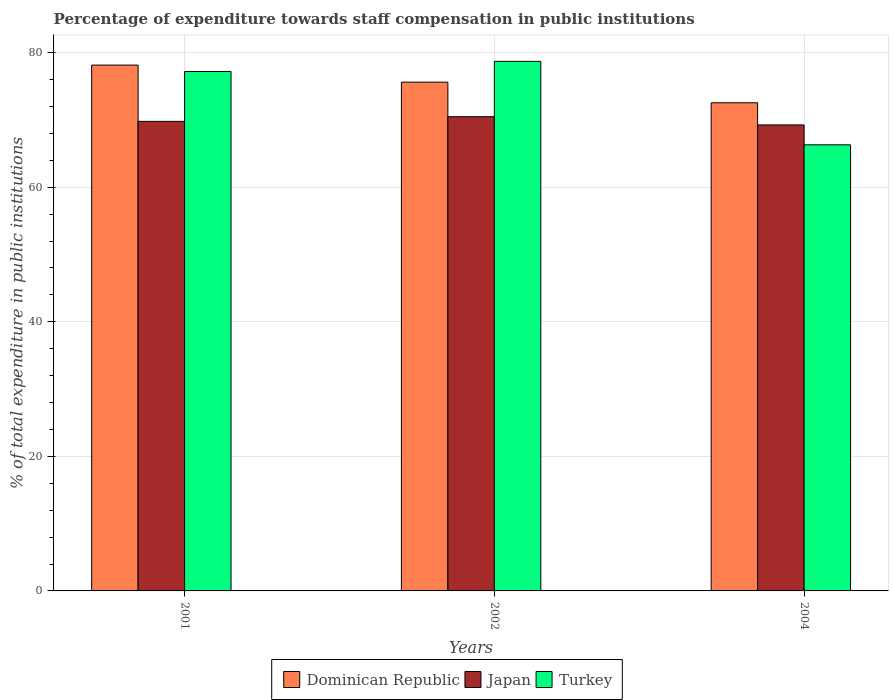How many different coloured bars are there?
Make the answer very short. 3. Are the number of bars per tick equal to the number of legend labels?
Provide a short and direct response. Yes. In how many cases, is the number of bars for a given year not equal to the number of legend labels?
Provide a succinct answer. 0. What is the percentage of expenditure towards staff compensation in Turkey in 2001?
Your answer should be very brief. 77.2. Across all years, what is the maximum percentage of expenditure towards staff compensation in Turkey?
Offer a very short reply. 78.71. Across all years, what is the minimum percentage of expenditure towards staff compensation in Dominican Republic?
Your answer should be very brief. 72.55. In which year was the percentage of expenditure towards staff compensation in Dominican Republic minimum?
Make the answer very short. 2004. What is the total percentage of expenditure towards staff compensation in Dominican Republic in the graph?
Your answer should be very brief. 226.33. What is the difference between the percentage of expenditure towards staff compensation in Japan in 2001 and that in 2002?
Provide a succinct answer. -0.69. What is the difference between the percentage of expenditure towards staff compensation in Japan in 2002 and the percentage of expenditure towards staff compensation in Turkey in 2004?
Give a very brief answer. 4.18. What is the average percentage of expenditure towards staff compensation in Japan per year?
Provide a short and direct response. 69.85. In the year 2002, what is the difference between the percentage of expenditure towards staff compensation in Turkey and percentage of expenditure towards staff compensation in Japan?
Ensure brevity in your answer.  8.23. In how many years, is the percentage of expenditure towards staff compensation in Japan greater than 32 %?
Your answer should be very brief. 3. What is the ratio of the percentage of expenditure towards staff compensation in Japan in 2001 to that in 2002?
Provide a succinct answer. 0.99. Is the percentage of expenditure towards staff compensation in Japan in 2001 less than that in 2004?
Your response must be concise. No. Is the difference between the percentage of expenditure towards staff compensation in Turkey in 2001 and 2002 greater than the difference between the percentage of expenditure towards staff compensation in Japan in 2001 and 2002?
Give a very brief answer. No. What is the difference between the highest and the second highest percentage of expenditure towards staff compensation in Turkey?
Ensure brevity in your answer.  1.51. What is the difference between the highest and the lowest percentage of expenditure towards staff compensation in Japan?
Provide a succinct answer. 1.22. Is the sum of the percentage of expenditure towards staff compensation in Turkey in 2002 and 2004 greater than the maximum percentage of expenditure towards staff compensation in Dominican Republic across all years?
Your answer should be very brief. Yes. What does the 3rd bar from the left in 2001 represents?
Your answer should be compact. Turkey. How many bars are there?
Provide a short and direct response. 9. What is the difference between two consecutive major ticks on the Y-axis?
Your answer should be compact. 20. Are the values on the major ticks of Y-axis written in scientific E-notation?
Make the answer very short. No. Does the graph contain any zero values?
Your answer should be compact. No. Does the graph contain grids?
Keep it short and to the point. Yes. How are the legend labels stacked?
Your answer should be compact. Horizontal. What is the title of the graph?
Ensure brevity in your answer.  Percentage of expenditure towards staff compensation in public institutions. What is the label or title of the X-axis?
Offer a terse response. Years. What is the label or title of the Y-axis?
Provide a short and direct response. % of total expenditure in public institutions. What is the % of total expenditure in public institutions in Dominican Republic in 2001?
Keep it short and to the point. 78.15. What is the % of total expenditure in public institutions in Japan in 2001?
Your response must be concise. 69.79. What is the % of total expenditure in public institutions of Turkey in 2001?
Your response must be concise. 77.2. What is the % of total expenditure in public institutions in Dominican Republic in 2002?
Ensure brevity in your answer.  75.62. What is the % of total expenditure in public institutions of Japan in 2002?
Provide a short and direct response. 70.48. What is the % of total expenditure in public institutions in Turkey in 2002?
Provide a succinct answer. 78.71. What is the % of total expenditure in public institutions of Dominican Republic in 2004?
Keep it short and to the point. 72.55. What is the % of total expenditure in public institutions of Japan in 2004?
Keep it short and to the point. 69.26. What is the % of total expenditure in public institutions in Turkey in 2004?
Offer a terse response. 66.3. Across all years, what is the maximum % of total expenditure in public institutions of Dominican Republic?
Provide a succinct answer. 78.15. Across all years, what is the maximum % of total expenditure in public institutions of Japan?
Keep it short and to the point. 70.48. Across all years, what is the maximum % of total expenditure in public institutions in Turkey?
Your answer should be compact. 78.71. Across all years, what is the minimum % of total expenditure in public institutions of Dominican Republic?
Provide a succinct answer. 72.55. Across all years, what is the minimum % of total expenditure in public institutions of Japan?
Offer a very short reply. 69.26. Across all years, what is the minimum % of total expenditure in public institutions in Turkey?
Offer a very short reply. 66.3. What is the total % of total expenditure in public institutions of Dominican Republic in the graph?
Your answer should be very brief. 226.33. What is the total % of total expenditure in public institutions of Japan in the graph?
Keep it short and to the point. 209.54. What is the total % of total expenditure in public institutions in Turkey in the graph?
Ensure brevity in your answer.  222.22. What is the difference between the % of total expenditure in public institutions of Dominican Republic in 2001 and that in 2002?
Offer a terse response. 2.53. What is the difference between the % of total expenditure in public institutions of Japan in 2001 and that in 2002?
Your answer should be compact. -0.69. What is the difference between the % of total expenditure in public institutions in Turkey in 2001 and that in 2002?
Provide a short and direct response. -1.51. What is the difference between the % of total expenditure in public institutions in Dominican Republic in 2001 and that in 2004?
Offer a terse response. 5.6. What is the difference between the % of total expenditure in public institutions in Japan in 2001 and that in 2004?
Provide a short and direct response. 0.53. What is the difference between the % of total expenditure in public institutions in Turkey in 2001 and that in 2004?
Offer a very short reply. 10.9. What is the difference between the % of total expenditure in public institutions in Dominican Republic in 2002 and that in 2004?
Your response must be concise. 3.06. What is the difference between the % of total expenditure in public institutions in Japan in 2002 and that in 2004?
Make the answer very short. 1.22. What is the difference between the % of total expenditure in public institutions of Turkey in 2002 and that in 2004?
Your answer should be very brief. 12.41. What is the difference between the % of total expenditure in public institutions in Dominican Republic in 2001 and the % of total expenditure in public institutions in Japan in 2002?
Offer a terse response. 7.67. What is the difference between the % of total expenditure in public institutions in Dominican Republic in 2001 and the % of total expenditure in public institutions in Turkey in 2002?
Provide a short and direct response. -0.56. What is the difference between the % of total expenditure in public institutions of Japan in 2001 and the % of total expenditure in public institutions of Turkey in 2002?
Offer a very short reply. -8.92. What is the difference between the % of total expenditure in public institutions of Dominican Republic in 2001 and the % of total expenditure in public institutions of Japan in 2004?
Your response must be concise. 8.89. What is the difference between the % of total expenditure in public institutions of Dominican Republic in 2001 and the % of total expenditure in public institutions of Turkey in 2004?
Provide a succinct answer. 11.85. What is the difference between the % of total expenditure in public institutions in Japan in 2001 and the % of total expenditure in public institutions in Turkey in 2004?
Keep it short and to the point. 3.49. What is the difference between the % of total expenditure in public institutions in Dominican Republic in 2002 and the % of total expenditure in public institutions in Japan in 2004?
Make the answer very short. 6.36. What is the difference between the % of total expenditure in public institutions of Dominican Republic in 2002 and the % of total expenditure in public institutions of Turkey in 2004?
Ensure brevity in your answer.  9.31. What is the difference between the % of total expenditure in public institutions of Japan in 2002 and the % of total expenditure in public institutions of Turkey in 2004?
Keep it short and to the point. 4.18. What is the average % of total expenditure in public institutions of Dominican Republic per year?
Provide a short and direct response. 75.44. What is the average % of total expenditure in public institutions in Japan per year?
Make the answer very short. 69.85. What is the average % of total expenditure in public institutions in Turkey per year?
Keep it short and to the point. 74.07. In the year 2001, what is the difference between the % of total expenditure in public institutions of Dominican Republic and % of total expenditure in public institutions of Japan?
Make the answer very short. 8.36. In the year 2001, what is the difference between the % of total expenditure in public institutions of Dominican Republic and % of total expenditure in public institutions of Turkey?
Offer a very short reply. 0.95. In the year 2001, what is the difference between the % of total expenditure in public institutions of Japan and % of total expenditure in public institutions of Turkey?
Provide a short and direct response. -7.41. In the year 2002, what is the difference between the % of total expenditure in public institutions of Dominican Republic and % of total expenditure in public institutions of Japan?
Offer a very short reply. 5.14. In the year 2002, what is the difference between the % of total expenditure in public institutions of Dominican Republic and % of total expenditure in public institutions of Turkey?
Give a very brief answer. -3.09. In the year 2002, what is the difference between the % of total expenditure in public institutions in Japan and % of total expenditure in public institutions in Turkey?
Offer a very short reply. -8.23. In the year 2004, what is the difference between the % of total expenditure in public institutions of Dominican Republic and % of total expenditure in public institutions of Japan?
Your response must be concise. 3.29. In the year 2004, what is the difference between the % of total expenditure in public institutions in Dominican Republic and % of total expenditure in public institutions in Turkey?
Make the answer very short. 6.25. In the year 2004, what is the difference between the % of total expenditure in public institutions in Japan and % of total expenditure in public institutions in Turkey?
Offer a terse response. 2.96. What is the ratio of the % of total expenditure in public institutions in Dominican Republic in 2001 to that in 2002?
Keep it short and to the point. 1.03. What is the ratio of the % of total expenditure in public institutions in Japan in 2001 to that in 2002?
Your answer should be very brief. 0.99. What is the ratio of the % of total expenditure in public institutions in Turkey in 2001 to that in 2002?
Give a very brief answer. 0.98. What is the ratio of the % of total expenditure in public institutions of Dominican Republic in 2001 to that in 2004?
Provide a short and direct response. 1.08. What is the ratio of the % of total expenditure in public institutions in Japan in 2001 to that in 2004?
Your response must be concise. 1.01. What is the ratio of the % of total expenditure in public institutions in Turkey in 2001 to that in 2004?
Give a very brief answer. 1.16. What is the ratio of the % of total expenditure in public institutions in Dominican Republic in 2002 to that in 2004?
Your answer should be very brief. 1.04. What is the ratio of the % of total expenditure in public institutions of Japan in 2002 to that in 2004?
Your response must be concise. 1.02. What is the ratio of the % of total expenditure in public institutions in Turkey in 2002 to that in 2004?
Provide a succinct answer. 1.19. What is the difference between the highest and the second highest % of total expenditure in public institutions in Dominican Republic?
Your response must be concise. 2.53. What is the difference between the highest and the second highest % of total expenditure in public institutions in Japan?
Your response must be concise. 0.69. What is the difference between the highest and the second highest % of total expenditure in public institutions in Turkey?
Provide a succinct answer. 1.51. What is the difference between the highest and the lowest % of total expenditure in public institutions in Dominican Republic?
Keep it short and to the point. 5.6. What is the difference between the highest and the lowest % of total expenditure in public institutions of Japan?
Ensure brevity in your answer.  1.22. What is the difference between the highest and the lowest % of total expenditure in public institutions in Turkey?
Your answer should be very brief. 12.41. 